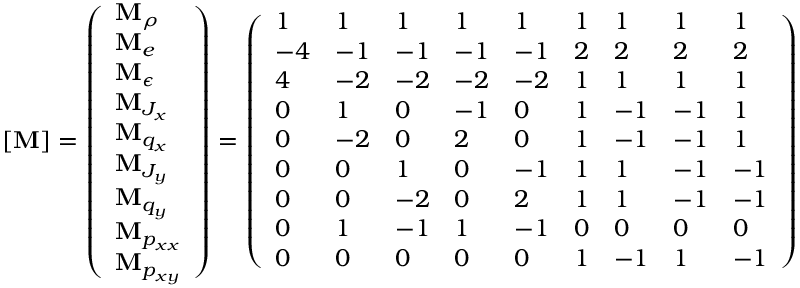Convert formula to latex. <formula><loc_0><loc_0><loc_500><loc_500>[ M ] = \left ( \begin{array} { l } { M _ { \rho } } \\ { M _ { e } } \\ { M _ { \epsilon } } \\ { M _ { J _ { x } } } \\ { M _ { q _ { x } } } \\ { M _ { J _ { y } } } \\ { M _ { q _ { y } } } \\ { M _ { p _ { x x } } } \\ { M _ { p _ { x y } } } \end{array} \right ) = \left ( \begin{array} { l l l l l l l l l } { 1 } & { 1 } & { 1 } & { 1 } & { 1 } & { 1 } & { 1 } & { 1 } & { 1 } \\ { - 4 } & { - 1 } & { - 1 } & { - 1 } & { - 1 } & { 2 } & { 2 } & { 2 } & { 2 } \\ { 4 } & { - 2 } & { - 2 } & { - 2 } & { - 2 } & { 1 } & { 1 } & { 1 } & { 1 } \\ { 0 } & { 1 } & { 0 } & { - 1 } & { 0 } & { 1 } & { - 1 } & { - 1 } & { 1 } \\ { 0 } & { - 2 } & { 0 } & { 2 } & { 0 } & { 1 } & { - 1 } & { - 1 } & { 1 } \\ { 0 } & { 0 } & { 1 } & { 0 } & { - 1 } & { 1 } & { 1 } & { - 1 } & { - 1 } \\ { 0 } & { 0 } & { - 2 } & { 0 } & { 2 } & { 1 } & { 1 } & { - 1 } & { - 1 } \\ { 0 } & { 1 } & { - 1 } & { 1 } & { - 1 } & { 0 } & { 0 } & { 0 } & { 0 } \\ { 0 } & { 0 } & { 0 } & { 0 } & { 0 } & { 1 } & { - 1 } & { 1 } & { - 1 } \end{array} \right )</formula> 